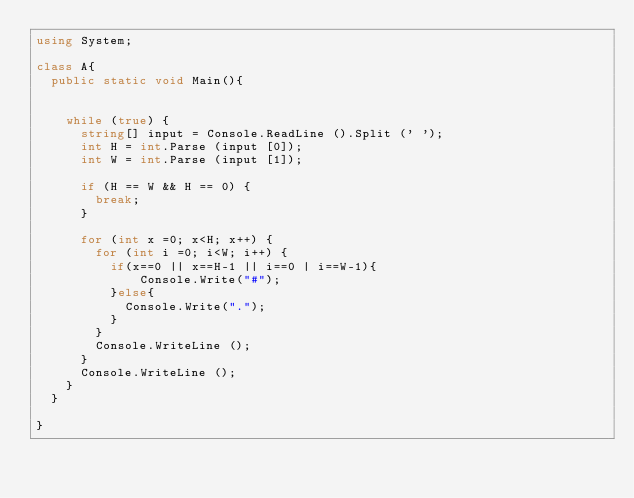Convert code to text. <code><loc_0><loc_0><loc_500><loc_500><_C#_>using System;

class A{
	public static void Main(){


		while (true) {
			string[] input = Console.ReadLine ().Split (' ');
			int H = int.Parse (input [0]);
			int W = int.Parse (input [1]);
		 
			if (H == W && H == 0) {
				break;
			}
		
			for (int x =0; x<H; x++) {
				for (int i =0; i<W; i++) {
					if(x==0 || x==H-1 || i==0 | i==W-1){
							Console.Write("#");
					}else{
						Console.Write(".");
					}
				}
				Console.WriteLine ();
			}
			Console.WriteLine ();
		}	
	}

}</code> 